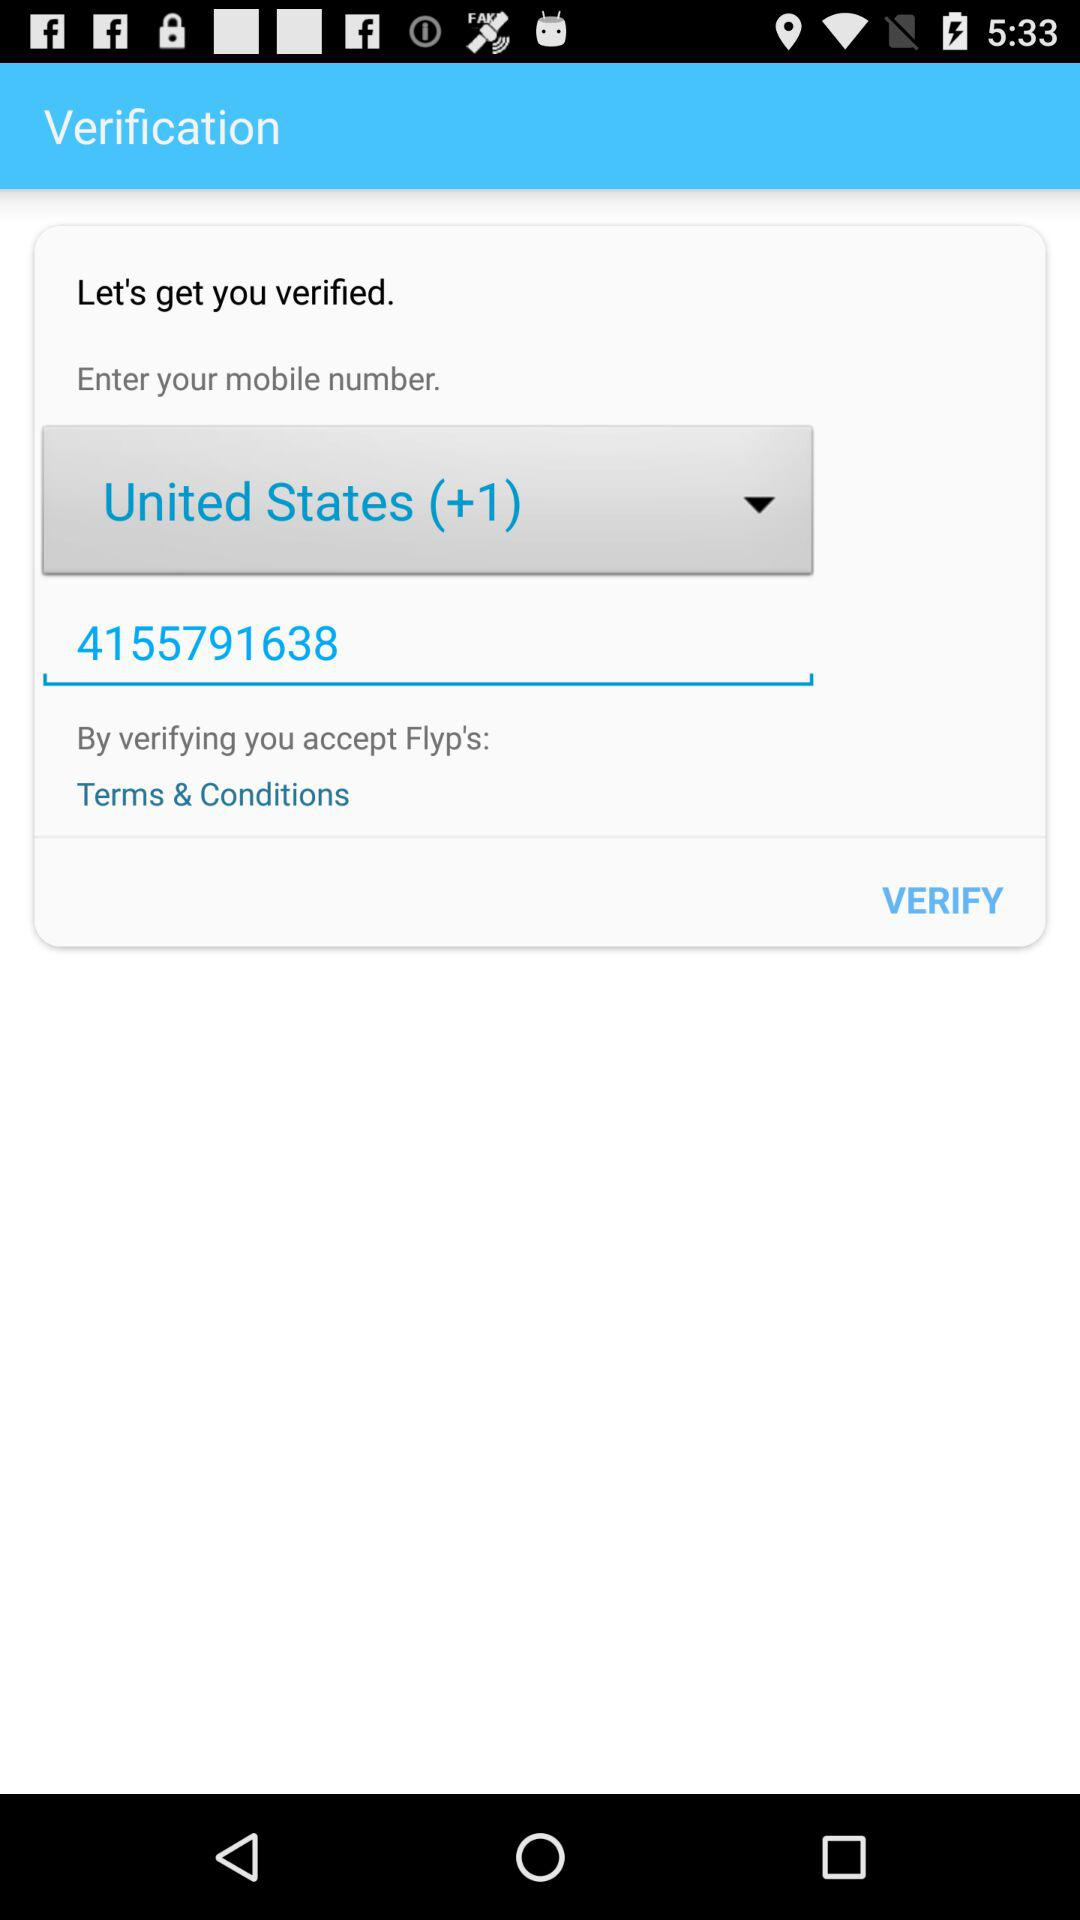Which country code is selected? The selected country code is "United States (+1)". 